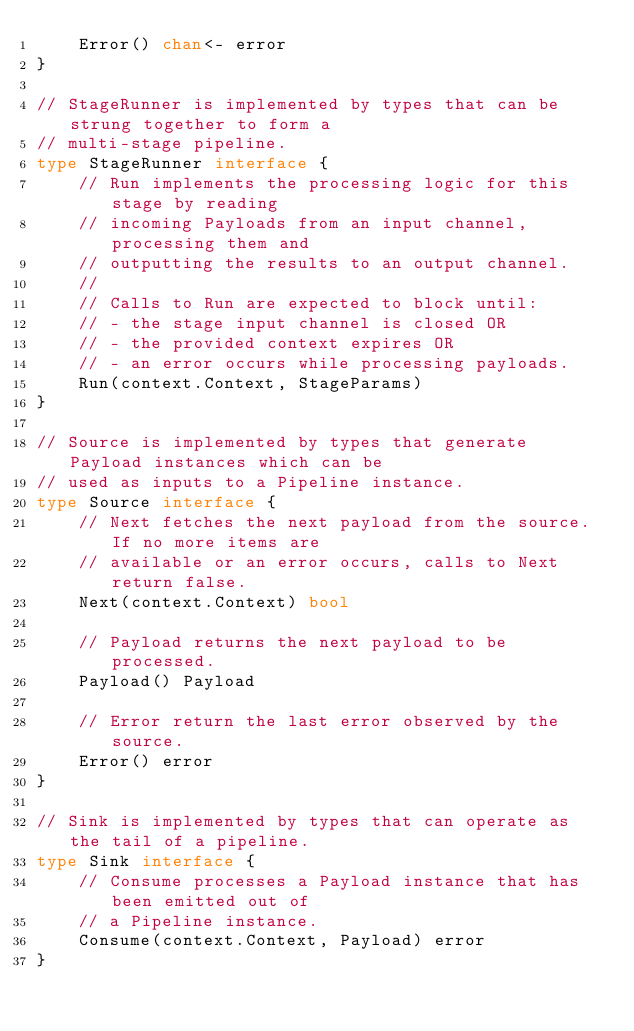Convert code to text. <code><loc_0><loc_0><loc_500><loc_500><_Go_>	Error() chan<- error
}

// StageRunner is implemented by types that can be strung together to form a
// multi-stage pipeline.
type StageRunner interface {
	// Run implements the processing logic for this stage by reading
	// incoming Payloads from an input channel, processing them and
	// outputting the results to an output channel.
	//
	// Calls to Run are expected to block until:
	// - the stage input channel is closed OR
	// - the provided context expires OR
	// - an error occurs while processing payloads.
	Run(context.Context, StageParams)
}

// Source is implemented by types that generate Payload instances which can be
// used as inputs to a Pipeline instance.
type Source interface {
	// Next fetches the next payload from the source. If no more items are
	// available or an error occurs, calls to Next return false.
	Next(context.Context) bool

	// Payload returns the next payload to be processed.
	Payload() Payload

	// Error return the last error observed by the source.
	Error() error
}

// Sink is implemented by types that can operate as the tail of a pipeline.
type Sink interface {
	// Consume processes a Payload instance that has been emitted out of
	// a Pipeline instance.
	Consume(context.Context, Payload) error
}
</code> 